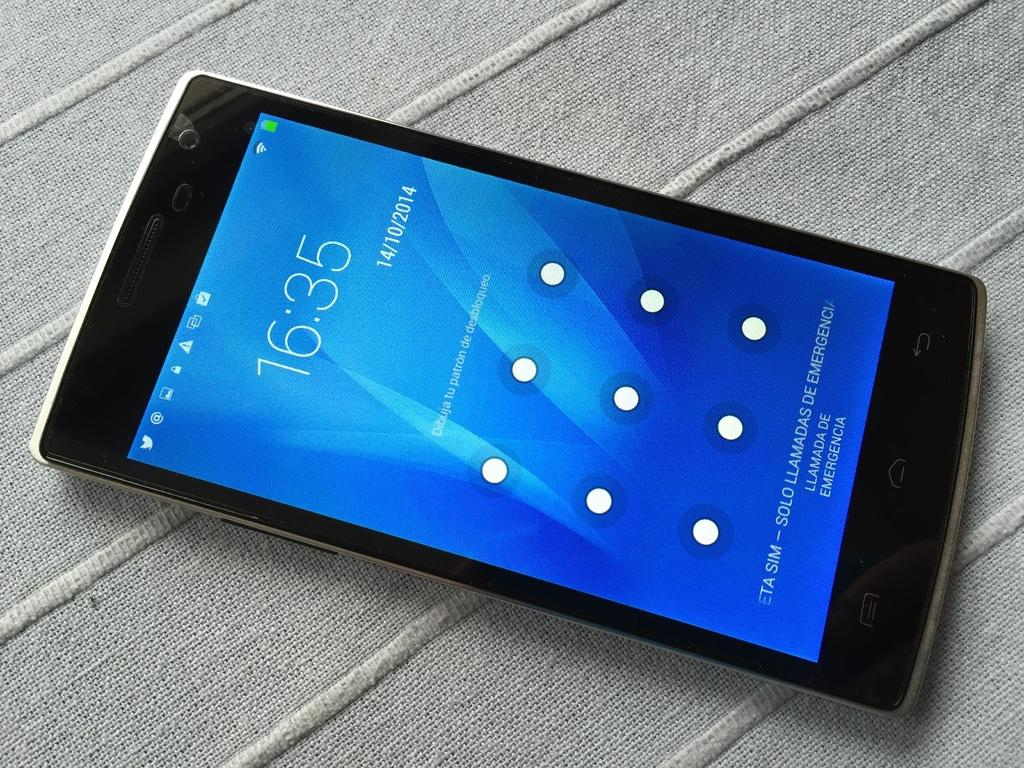<image>
Create a compact narrative representing the image presented. A product shot of a cell phone showing the blue lock screen and the time 16:35. 